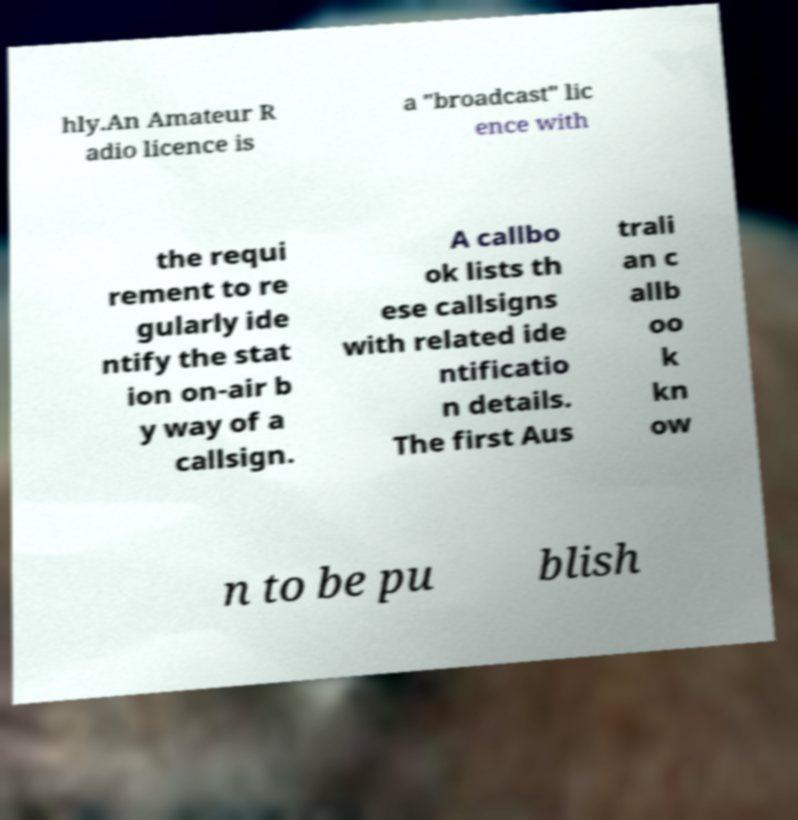I need the written content from this picture converted into text. Can you do that? hly.An Amateur R adio licence is a "broadcast" lic ence with the requi rement to re gularly ide ntify the stat ion on-air b y way of a callsign. A callbo ok lists th ese callsigns with related ide ntificatio n details. The first Aus trali an c allb oo k kn ow n to be pu blish 